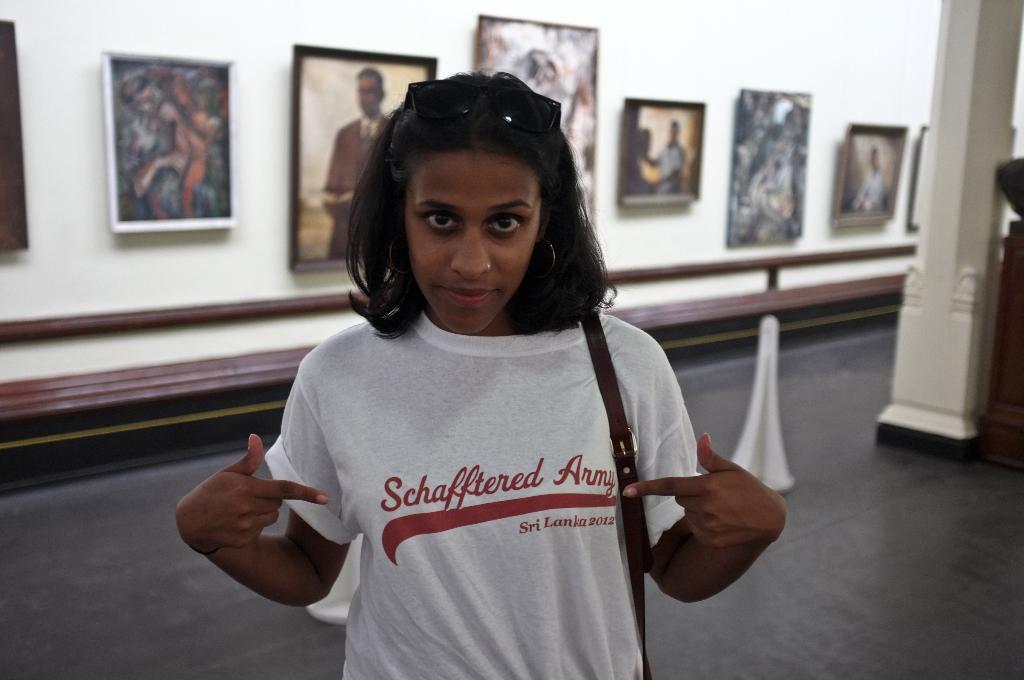How would you summarize this image in a sentence or two? In this image there is a lady standing. On the right there is a pillar. In the background there is a wall and we can see photo frames placed on the wall. 